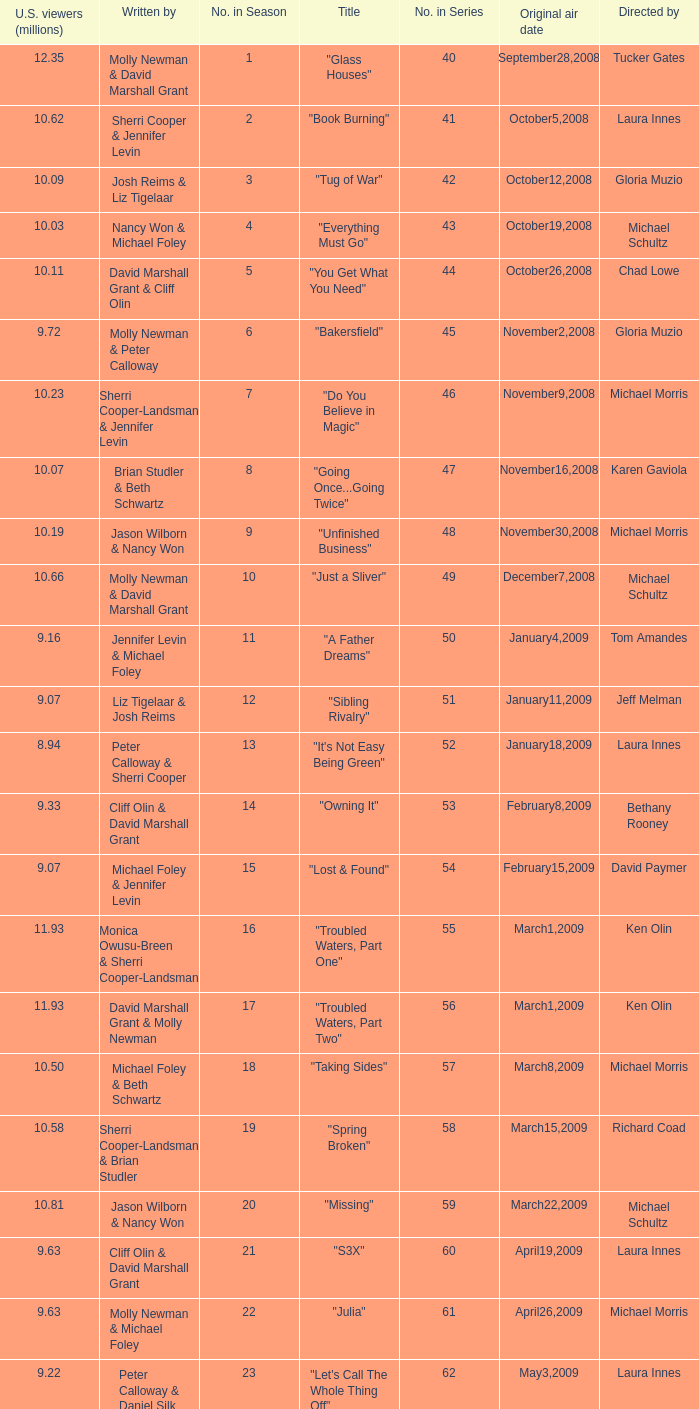When did the episode viewed by 10.50 millions of people in the US run for the first time? March8,2009. 